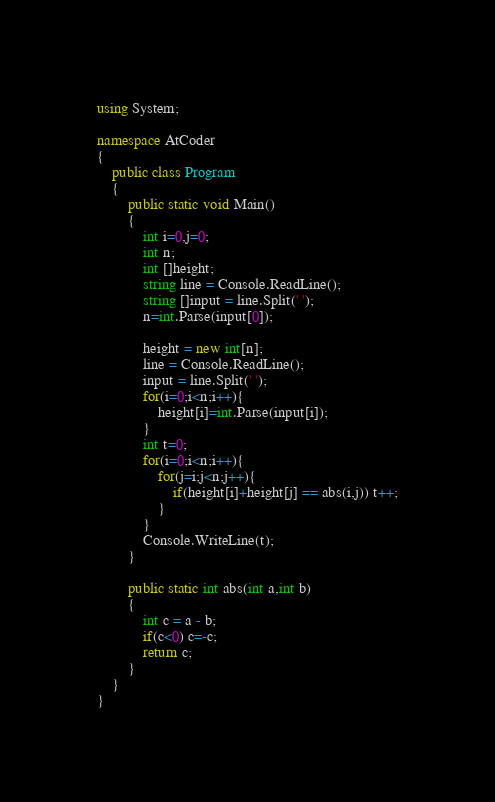<code> <loc_0><loc_0><loc_500><loc_500><_C#_>using System;

namespace AtCoder
{
    public class Program
    {
        public static void Main()
        {
            int i=0,j=0;
            int n;
            int []height;
            string line = Console.ReadLine();
            string []input = line.Split(' ');
            n=int.Parse(input[0]);

            height = new int[n];
            line = Console.ReadLine();
            input = line.Split(' ');
            for(i=0;i<n;i++){
                height[i]=int.Parse(input[i]);
            }
            int t=0;
            for(i=0;i<n;i++){
                for(j=i;j<n;j++){
                    if(height[i]+height[j] == abs(i,j)) t++;
                }
            }
            Console.WriteLine(t);
        }

        public static int abs(int a,int b)
        {
            int c = a - b;
            if(c<0) c=-c;
            return c;
        }
    }
}</code> 